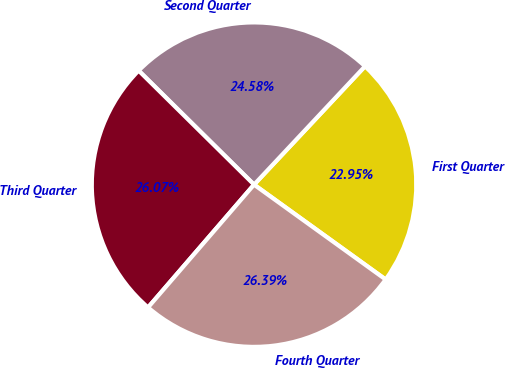<chart> <loc_0><loc_0><loc_500><loc_500><pie_chart><fcel>First Quarter<fcel>Second Quarter<fcel>Third Quarter<fcel>Fourth Quarter<nl><fcel>22.95%<fcel>24.58%<fcel>26.07%<fcel>26.39%<nl></chart> 